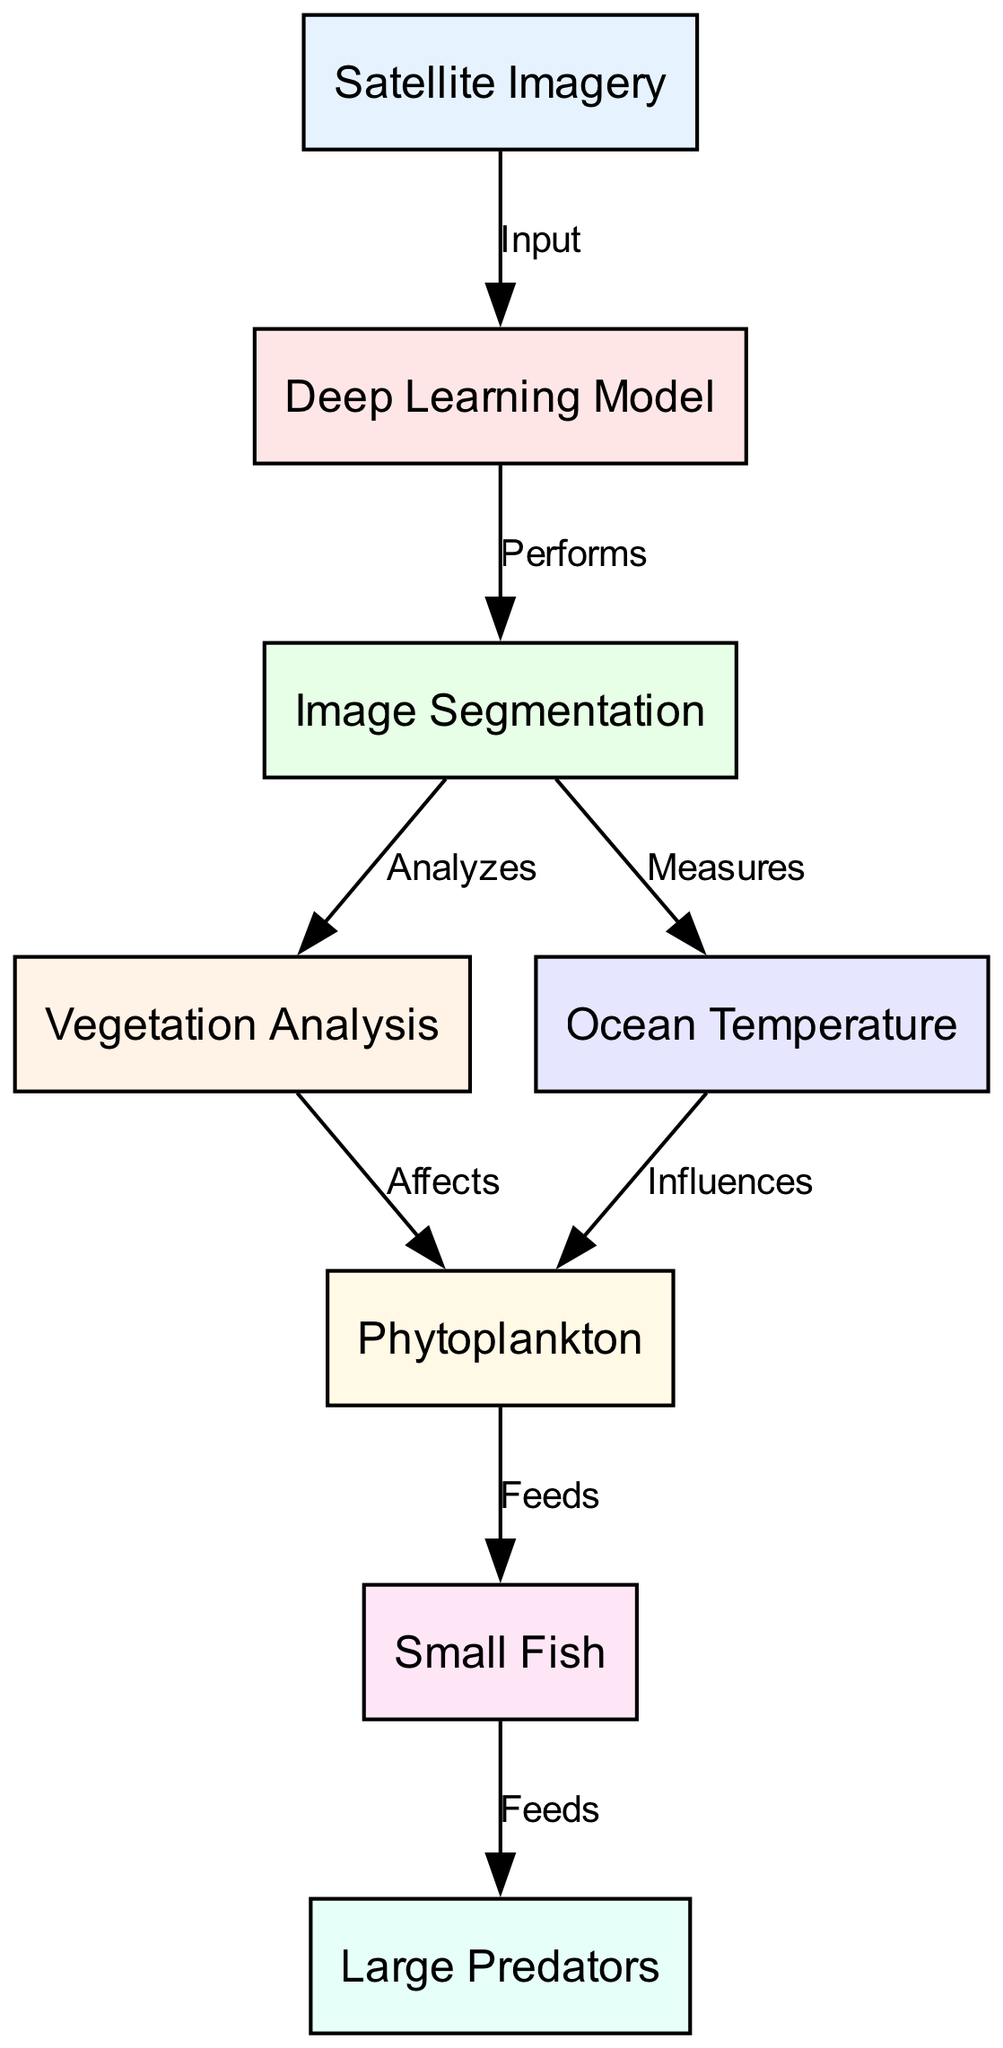What is the first node in the diagram? The first node listed in the diagram is "Satellite Imagery," as it is identified as the starting point in the flow of the diagram.
Answer: Satellite Imagery How many nodes are present in the diagram? By counting each unique identifier in the 'nodes' section, there are 8 distinct nodes shown in the diagram.
Answer: 8 What relationship does the "Deep Learning Model" have with "Image Segmentation"? The label on the edge between "Deep Learning Model" and "Image Segmentation" specifies that the model "Performs" the image segmentation, indicating a direct functional relationship.
Answer: Performs Which node feeds into "Large Predators"? The edge shows that "Small Fish" is positioned prior to and connected to "Large Predators" indicating that it serves as a food source or resource for them.
Answer: Small Fish What are the two factors that influence "Phytoplankton"? The edges leading into "Phytoplankton" are labeled "Affects" from "Vegetation Analysis" and "Influences" from "Ocean Temperature," indicating these two factors impact phytoplankton growth.
Answer: Vegetation Analysis and Ocean Temperature What node analyzes vegetation? The edge directed from "Image Segmentation" to "Vegetation Analysis" is labeled "Analyzes," thus identifying "Vegetation Analysis" as the node that analyzes vegetation.
Answer: Vegetation Analysis How does "Ocean Temperature" affect the food chain? "Ocean Temperature" influences "Phytoplankton," which is a critical source of food, leading to the sustenance of "Small Fish," thereby affecting the entire food chain.
Answer: Influences Phytoplankton What is the direction of flow from "Phytoplankton" to "Small Fish"? The edge labeled "Feeds" directly connects "Phytoplankton" to "Small Fish," indicating a direct feeding relationship in the context of the food chain represented.
Answer: Feeds Which node is the last in the flow of the diagram? The final node, which does not feed into any other node or have outgoing relationships, is "Large Predators," capturing the ultimate point in this food chain.
Answer: Large Predators 